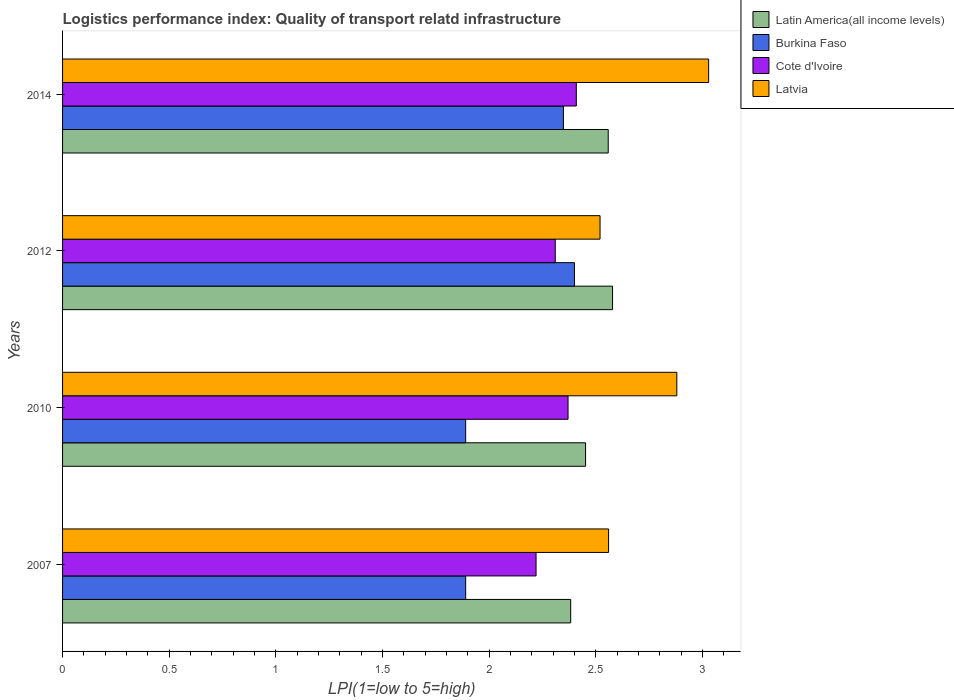How many groups of bars are there?
Make the answer very short. 4. Are the number of bars per tick equal to the number of legend labels?
Offer a terse response. Yes. Are the number of bars on each tick of the Y-axis equal?
Your answer should be compact. Yes. How many bars are there on the 1st tick from the top?
Your answer should be very brief. 4. How many bars are there on the 3rd tick from the bottom?
Give a very brief answer. 4. In how many cases, is the number of bars for a given year not equal to the number of legend labels?
Your response must be concise. 0. What is the logistics performance index in Burkina Faso in 2007?
Give a very brief answer. 1.89. Across all years, what is the maximum logistics performance index in Latin America(all income levels)?
Your answer should be compact. 2.58. Across all years, what is the minimum logistics performance index in Cote d'Ivoire?
Your answer should be compact. 2.22. What is the total logistics performance index in Burkina Faso in the graph?
Give a very brief answer. 8.53. What is the difference between the logistics performance index in Cote d'Ivoire in 2010 and that in 2012?
Provide a short and direct response. 0.06. What is the difference between the logistics performance index in Latvia in 2014 and the logistics performance index in Cote d'Ivoire in 2007?
Keep it short and to the point. 0.81. What is the average logistics performance index in Cote d'Ivoire per year?
Give a very brief answer. 2.33. In the year 2010, what is the difference between the logistics performance index in Latvia and logistics performance index in Cote d'Ivoire?
Your answer should be compact. 0.51. What is the ratio of the logistics performance index in Burkina Faso in 2007 to that in 2012?
Ensure brevity in your answer.  0.79. Is the logistics performance index in Latvia in 2007 less than that in 2012?
Your answer should be compact. No. Is the difference between the logistics performance index in Latvia in 2010 and 2014 greater than the difference between the logistics performance index in Cote d'Ivoire in 2010 and 2014?
Your answer should be compact. No. What is the difference between the highest and the second highest logistics performance index in Burkina Faso?
Your response must be concise. 0.05. What is the difference between the highest and the lowest logistics performance index in Burkina Faso?
Provide a succinct answer. 0.51. In how many years, is the logistics performance index in Burkina Faso greater than the average logistics performance index in Burkina Faso taken over all years?
Give a very brief answer. 2. Is it the case that in every year, the sum of the logistics performance index in Cote d'Ivoire and logistics performance index in Latvia is greater than the sum of logistics performance index in Burkina Faso and logistics performance index in Latin America(all income levels)?
Give a very brief answer. Yes. What does the 4th bar from the top in 2014 represents?
Ensure brevity in your answer.  Latin America(all income levels). What does the 1st bar from the bottom in 2010 represents?
Offer a terse response. Latin America(all income levels). Are all the bars in the graph horizontal?
Provide a succinct answer. Yes. What is the difference between two consecutive major ticks on the X-axis?
Ensure brevity in your answer.  0.5. Are the values on the major ticks of X-axis written in scientific E-notation?
Your response must be concise. No. Does the graph contain grids?
Make the answer very short. No. How are the legend labels stacked?
Make the answer very short. Vertical. What is the title of the graph?
Make the answer very short. Logistics performance index: Quality of transport relatd infrastructure. Does "Faeroe Islands" appear as one of the legend labels in the graph?
Ensure brevity in your answer.  No. What is the label or title of the X-axis?
Keep it short and to the point. LPI(1=low to 5=high). What is the label or title of the Y-axis?
Make the answer very short. Years. What is the LPI(1=low to 5=high) of Latin America(all income levels) in 2007?
Offer a very short reply. 2.38. What is the LPI(1=low to 5=high) in Burkina Faso in 2007?
Make the answer very short. 1.89. What is the LPI(1=low to 5=high) in Cote d'Ivoire in 2007?
Give a very brief answer. 2.22. What is the LPI(1=low to 5=high) in Latvia in 2007?
Your response must be concise. 2.56. What is the LPI(1=low to 5=high) in Latin America(all income levels) in 2010?
Ensure brevity in your answer.  2.45. What is the LPI(1=low to 5=high) of Burkina Faso in 2010?
Make the answer very short. 1.89. What is the LPI(1=low to 5=high) of Cote d'Ivoire in 2010?
Keep it short and to the point. 2.37. What is the LPI(1=low to 5=high) in Latvia in 2010?
Give a very brief answer. 2.88. What is the LPI(1=low to 5=high) in Latin America(all income levels) in 2012?
Make the answer very short. 2.58. What is the LPI(1=low to 5=high) of Burkina Faso in 2012?
Give a very brief answer. 2.4. What is the LPI(1=low to 5=high) of Cote d'Ivoire in 2012?
Ensure brevity in your answer.  2.31. What is the LPI(1=low to 5=high) in Latvia in 2012?
Keep it short and to the point. 2.52. What is the LPI(1=low to 5=high) of Latin America(all income levels) in 2014?
Provide a short and direct response. 2.56. What is the LPI(1=low to 5=high) of Burkina Faso in 2014?
Keep it short and to the point. 2.35. What is the LPI(1=low to 5=high) in Cote d'Ivoire in 2014?
Keep it short and to the point. 2.41. What is the LPI(1=low to 5=high) of Latvia in 2014?
Provide a short and direct response. 3.03. Across all years, what is the maximum LPI(1=low to 5=high) of Latin America(all income levels)?
Your answer should be compact. 2.58. Across all years, what is the maximum LPI(1=low to 5=high) of Burkina Faso?
Offer a very short reply. 2.4. Across all years, what is the maximum LPI(1=low to 5=high) of Cote d'Ivoire?
Make the answer very short. 2.41. Across all years, what is the maximum LPI(1=low to 5=high) of Latvia?
Provide a short and direct response. 3.03. Across all years, what is the minimum LPI(1=low to 5=high) in Latin America(all income levels)?
Provide a short and direct response. 2.38. Across all years, what is the minimum LPI(1=low to 5=high) of Burkina Faso?
Make the answer very short. 1.89. Across all years, what is the minimum LPI(1=low to 5=high) of Cote d'Ivoire?
Provide a succinct answer. 2.22. Across all years, what is the minimum LPI(1=low to 5=high) of Latvia?
Keep it short and to the point. 2.52. What is the total LPI(1=low to 5=high) in Latin America(all income levels) in the graph?
Your answer should be compact. 9.97. What is the total LPI(1=low to 5=high) of Burkina Faso in the graph?
Your answer should be compact. 8.53. What is the total LPI(1=low to 5=high) in Cote d'Ivoire in the graph?
Keep it short and to the point. 9.31. What is the total LPI(1=low to 5=high) in Latvia in the graph?
Ensure brevity in your answer.  10.99. What is the difference between the LPI(1=low to 5=high) in Latin America(all income levels) in 2007 and that in 2010?
Your answer should be very brief. -0.07. What is the difference between the LPI(1=low to 5=high) in Burkina Faso in 2007 and that in 2010?
Make the answer very short. 0. What is the difference between the LPI(1=low to 5=high) of Cote d'Ivoire in 2007 and that in 2010?
Offer a terse response. -0.15. What is the difference between the LPI(1=low to 5=high) in Latvia in 2007 and that in 2010?
Provide a succinct answer. -0.32. What is the difference between the LPI(1=low to 5=high) of Latin America(all income levels) in 2007 and that in 2012?
Make the answer very short. -0.2. What is the difference between the LPI(1=low to 5=high) in Burkina Faso in 2007 and that in 2012?
Make the answer very short. -0.51. What is the difference between the LPI(1=low to 5=high) of Cote d'Ivoire in 2007 and that in 2012?
Make the answer very short. -0.09. What is the difference between the LPI(1=low to 5=high) of Latvia in 2007 and that in 2012?
Ensure brevity in your answer.  0.04. What is the difference between the LPI(1=low to 5=high) in Latin America(all income levels) in 2007 and that in 2014?
Offer a very short reply. -0.18. What is the difference between the LPI(1=low to 5=high) in Burkina Faso in 2007 and that in 2014?
Ensure brevity in your answer.  -0.46. What is the difference between the LPI(1=low to 5=high) in Cote d'Ivoire in 2007 and that in 2014?
Give a very brief answer. -0.19. What is the difference between the LPI(1=low to 5=high) in Latvia in 2007 and that in 2014?
Make the answer very short. -0.47. What is the difference between the LPI(1=low to 5=high) in Latin America(all income levels) in 2010 and that in 2012?
Your answer should be compact. -0.13. What is the difference between the LPI(1=low to 5=high) of Burkina Faso in 2010 and that in 2012?
Give a very brief answer. -0.51. What is the difference between the LPI(1=low to 5=high) of Cote d'Ivoire in 2010 and that in 2012?
Make the answer very short. 0.06. What is the difference between the LPI(1=low to 5=high) of Latvia in 2010 and that in 2012?
Offer a very short reply. 0.36. What is the difference between the LPI(1=low to 5=high) of Latin America(all income levels) in 2010 and that in 2014?
Ensure brevity in your answer.  -0.11. What is the difference between the LPI(1=low to 5=high) of Burkina Faso in 2010 and that in 2014?
Provide a short and direct response. -0.46. What is the difference between the LPI(1=low to 5=high) in Cote d'Ivoire in 2010 and that in 2014?
Your response must be concise. -0.04. What is the difference between the LPI(1=low to 5=high) of Latvia in 2010 and that in 2014?
Offer a very short reply. -0.15. What is the difference between the LPI(1=low to 5=high) of Latin America(all income levels) in 2012 and that in 2014?
Offer a terse response. 0.02. What is the difference between the LPI(1=low to 5=high) of Burkina Faso in 2012 and that in 2014?
Keep it short and to the point. 0.05. What is the difference between the LPI(1=low to 5=high) in Cote d'Ivoire in 2012 and that in 2014?
Keep it short and to the point. -0.1. What is the difference between the LPI(1=low to 5=high) of Latvia in 2012 and that in 2014?
Make the answer very short. -0.51. What is the difference between the LPI(1=low to 5=high) of Latin America(all income levels) in 2007 and the LPI(1=low to 5=high) of Burkina Faso in 2010?
Offer a very short reply. 0.49. What is the difference between the LPI(1=low to 5=high) in Latin America(all income levels) in 2007 and the LPI(1=low to 5=high) in Cote d'Ivoire in 2010?
Keep it short and to the point. 0.01. What is the difference between the LPI(1=low to 5=high) of Latin America(all income levels) in 2007 and the LPI(1=low to 5=high) of Latvia in 2010?
Offer a very short reply. -0.5. What is the difference between the LPI(1=low to 5=high) in Burkina Faso in 2007 and the LPI(1=low to 5=high) in Cote d'Ivoire in 2010?
Your response must be concise. -0.48. What is the difference between the LPI(1=low to 5=high) in Burkina Faso in 2007 and the LPI(1=low to 5=high) in Latvia in 2010?
Your response must be concise. -0.99. What is the difference between the LPI(1=low to 5=high) of Cote d'Ivoire in 2007 and the LPI(1=low to 5=high) of Latvia in 2010?
Make the answer very short. -0.66. What is the difference between the LPI(1=low to 5=high) of Latin America(all income levels) in 2007 and the LPI(1=low to 5=high) of Burkina Faso in 2012?
Keep it short and to the point. -0.02. What is the difference between the LPI(1=low to 5=high) in Latin America(all income levels) in 2007 and the LPI(1=low to 5=high) in Cote d'Ivoire in 2012?
Ensure brevity in your answer.  0.07. What is the difference between the LPI(1=low to 5=high) in Latin America(all income levels) in 2007 and the LPI(1=low to 5=high) in Latvia in 2012?
Provide a succinct answer. -0.14. What is the difference between the LPI(1=low to 5=high) in Burkina Faso in 2007 and the LPI(1=low to 5=high) in Cote d'Ivoire in 2012?
Keep it short and to the point. -0.42. What is the difference between the LPI(1=low to 5=high) in Burkina Faso in 2007 and the LPI(1=low to 5=high) in Latvia in 2012?
Ensure brevity in your answer.  -0.63. What is the difference between the LPI(1=low to 5=high) in Latin America(all income levels) in 2007 and the LPI(1=low to 5=high) in Burkina Faso in 2014?
Make the answer very short. 0.03. What is the difference between the LPI(1=low to 5=high) in Latin America(all income levels) in 2007 and the LPI(1=low to 5=high) in Cote d'Ivoire in 2014?
Offer a terse response. -0.03. What is the difference between the LPI(1=low to 5=high) of Latin America(all income levels) in 2007 and the LPI(1=low to 5=high) of Latvia in 2014?
Your response must be concise. -0.65. What is the difference between the LPI(1=low to 5=high) in Burkina Faso in 2007 and the LPI(1=low to 5=high) in Cote d'Ivoire in 2014?
Offer a very short reply. -0.52. What is the difference between the LPI(1=low to 5=high) of Burkina Faso in 2007 and the LPI(1=low to 5=high) of Latvia in 2014?
Make the answer very short. -1.14. What is the difference between the LPI(1=low to 5=high) of Cote d'Ivoire in 2007 and the LPI(1=low to 5=high) of Latvia in 2014?
Give a very brief answer. -0.81. What is the difference between the LPI(1=low to 5=high) of Latin America(all income levels) in 2010 and the LPI(1=low to 5=high) of Burkina Faso in 2012?
Your answer should be very brief. 0.05. What is the difference between the LPI(1=low to 5=high) in Latin America(all income levels) in 2010 and the LPI(1=low to 5=high) in Cote d'Ivoire in 2012?
Offer a terse response. 0.14. What is the difference between the LPI(1=low to 5=high) of Latin America(all income levels) in 2010 and the LPI(1=low to 5=high) of Latvia in 2012?
Your response must be concise. -0.07. What is the difference between the LPI(1=low to 5=high) in Burkina Faso in 2010 and the LPI(1=low to 5=high) in Cote d'Ivoire in 2012?
Provide a succinct answer. -0.42. What is the difference between the LPI(1=low to 5=high) of Burkina Faso in 2010 and the LPI(1=low to 5=high) of Latvia in 2012?
Provide a succinct answer. -0.63. What is the difference between the LPI(1=low to 5=high) in Cote d'Ivoire in 2010 and the LPI(1=low to 5=high) in Latvia in 2012?
Provide a succinct answer. -0.15. What is the difference between the LPI(1=low to 5=high) in Latin America(all income levels) in 2010 and the LPI(1=low to 5=high) in Burkina Faso in 2014?
Provide a succinct answer. 0.1. What is the difference between the LPI(1=low to 5=high) in Latin America(all income levels) in 2010 and the LPI(1=low to 5=high) in Cote d'Ivoire in 2014?
Offer a very short reply. 0.04. What is the difference between the LPI(1=low to 5=high) of Latin America(all income levels) in 2010 and the LPI(1=low to 5=high) of Latvia in 2014?
Your response must be concise. -0.58. What is the difference between the LPI(1=low to 5=high) of Burkina Faso in 2010 and the LPI(1=low to 5=high) of Cote d'Ivoire in 2014?
Provide a short and direct response. -0.52. What is the difference between the LPI(1=low to 5=high) of Burkina Faso in 2010 and the LPI(1=low to 5=high) of Latvia in 2014?
Give a very brief answer. -1.14. What is the difference between the LPI(1=low to 5=high) in Cote d'Ivoire in 2010 and the LPI(1=low to 5=high) in Latvia in 2014?
Offer a very short reply. -0.66. What is the difference between the LPI(1=low to 5=high) in Latin America(all income levels) in 2012 and the LPI(1=low to 5=high) in Burkina Faso in 2014?
Offer a very short reply. 0.23. What is the difference between the LPI(1=low to 5=high) in Latin America(all income levels) in 2012 and the LPI(1=low to 5=high) in Cote d'Ivoire in 2014?
Your answer should be compact. 0.17. What is the difference between the LPI(1=low to 5=high) of Latin America(all income levels) in 2012 and the LPI(1=low to 5=high) of Latvia in 2014?
Offer a very short reply. -0.45. What is the difference between the LPI(1=low to 5=high) in Burkina Faso in 2012 and the LPI(1=low to 5=high) in Cote d'Ivoire in 2014?
Ensure brevity in your answer.  -0.01. What is the difference between the LPI(1=low to 5=high) of Burkina Faso in 2012 and the LPI(1=low to 5=high) of Latvia in 2014?
Keep it short and to the point. -0.63. What is the difference between the LPI(1=low to 5=high) in Cote d'Ivoire in 2012 and the LPI(1=low to 5=high) in Latvia in 2014?
Your answer should be compact. -0.72. What is the average LPI(1=low to 5=high) in Latin America(all income levels) per year?
Keep it short and to the point. 2.49. What is the average LPI(1=low to 5=high) of Burkina Faso per year?
Ensure brevity in your answer.  2.13. What is the average LPI(1=low to 5=high) in Cote d'Ivoire per year?
Provide a short and direct response. 2.33. What is the average LPI(1=low to 5=high) of Latvia per year?
Keep it short and to the point. 2.75. In the year 2007, what is the difference between the LPI(1=low to 5=high) in Latin America(all income levels) and LPI(1=low to 5=high) in Burkina Faso?
Provide a short and direct response. 0.49. In the year 2007, what is the difference between the LPI(1=low to 5=high) of Latin America(all income levels) and LPI(1=low to 5=high) of Cote d'Ivoire?
Keep it short and to the point. 0.16. In the year 2007, what is the difference between the LPI(1=low to 5=high) of Latin America(all income levels) and LPI(1=low to 5=high) of Latvia?
Make the answer very short. -0.18. In the year 2007, what is the difference between the LPI(1=low to 5=high) in Burkina Faso and LPI(1=low to 5=high) in Cote d'Ivoire?
Your response must be concise. -0.33. In the year 2007, what is the difference between the LPI(1=low to 5=high) in Burkina Faso and LPI(1=low to 5=high) in Latvia?
Ensure brevity in your answer.  -0.67. In the year 2007, what is the difference between the LPI(1=low to 5=high) in Cote d'Ivoire and LPI(1=low to 5=high) in Latvia?
Offer a very short reply. -0.34. In the year 2010, what is the difference between the LPI(1=low to 5=high) in Latin America(all income levels) and LPI(1=low to 5=high) in Burkina Faso?
Provide a short and direct response. 0.56. In the year 2010, what is the difference between the LPI(1=low to 5=high) in Latin America(all income levels) and LPI(1=low to 5=high) in Cote d'Ivoire?
Make the answer very short. 0.08. In the year 2010, what is the difference between the LPI(1=low to 5=high) in Latin America(all income levels) and LPI(1=low to 5=high) in Latvia?
Ensure brevity in your answer.  -0.43. In the year 2010, what is the difference between the LPI(1=low to 5=high) in Burkina Faso and LPI(1=low to 5=high) in Cote d'Ivoire?
Give a very brief answer. -0.48. In the year 2010, what is the difference between the LPI(1=low to 5=high) of Burkina Faso and LPI(1=low to 5=high) of Latvia?
Ensure brevity in your answer.  -0.99. In the year 2010, what is the difference between the LPI(1=low to 5=high) of Cote d'Ivoire and LPI(1=low to 5=high) of Latvia?
Provide a short and direct response. -0.51. In the year 2012, what is the difference between the LPI(1=low to 5=high) in Latin America(all income levels) and LPI(1=low to 5=high) in Burkina Faso?
Give a very brief answer. 0.18. In the year 2012, what is the difference between the LPI(1=low to 5=high) of Latin America(all income levels) and LPI(1=low to 5=high) of Cote d'Ivoire?
Offer a terse response. 0.27. In the year 2012, what is the difference between the LPI(1=low to 5=high) of Latin America(all income levels) and LPI(1=low to 5=high) of Latvia?
Your answer should be very brief. 0.06. In the year 2012, what is the difference between the LPI(1=low to 5=high) of Burkina Faso and LPI(1=low to 5=high) of Cote d'Ivoire?
Give a very brief answer. 0.09. In the year 2012, what is the difference between the LPI(1=low to 5=high) of Burkina Faso and LPI(1=low to 5=high) of Latvia?
Your response must be concise. -0.12. In the year 2012, what is the difference between the LPI(1=low to 5=high) of Cote d'Ivoire and LPI(1=low to 5=high) of Latvia?
Your answer should be very brief. -0.21. In the year 2014, what is the difference between the LPI(1=low to 5=high) in Latin America(all income levels) and LPI(1=low to 5=high) in Burkina Faso?
Provide a short and direct response. 0.21. In the year 2014, what is the difference between the LPI(1=low to 5=high) in Latin America(all income levels) and LPI(1=low to 5=high) in Cote d'Ivoire?
Give a very brief answer. 0.15. In the year 2014, what is the difference between the LPI(1=low to 5=high) of Latin America(all income levels) and LPI(1=low to 5=high) of Latvia?
Make the answer very short. -0.47. In the year 2014, what is the difference between the LPI(1=low to 5=high) of Burkina Faso and LPI(1=low to 5=high) of Cote d'Ivoire?
Your answer should be very brief. -0.06. In the year 2014, what is the difference between the LPI(1=low to 5=high) in Burkina Faso and LPI(1=low to 5=high) in Latvia?
Your response must be concise. -0.68. In the year 2014, what is the difference between the LPI(1=low to 5=high) in Cote d'Ivoire and LPI(1=low to 5=high) in Latvia?
Give a very brief answer. -0.62. What is the ratio of the LPI(1=low to 5=high) of Latin America(all income levels) in 2007 to that in 2010?
Your answer should be very brief. 0.97. What is the ratio of the LPI(1=low to 5=high) in Cote d'Ivoire in 2007 to that in 2010?
Offer a terse response. 0.94. What is the ratio of the LPI(1=low to 5=high) of Latvia in 2007 to that in 2010?
Your answer should be very brief. 0.89. What is the ratio of the LPI(1=low to 5=high) in Latin America(all income levels) in 2007 to that in 2012?
Your answer should be compact. 0.92. What is the ratio of the LPI(1=low to 5=high) of Burkina Faso in 2007 to that in 2012?
Provide a succinct answer. 0.79. What is the ratio of the LPI(1=low to 5=high) of Latvia in 2007 to that in 2012?
Keep it short and to the point. 1.02. What is the ratio of the LPI(1=low to 5=high) in Latin America(all income levels) in 2007 to that in 2014?
Offer a terse response. 0.93. What is the ratio of the LPI(1=low to 5=high) of Burkina Faso in 2007 to that in 2014?
Your answer should be very brief. 0.8. What is the ratio of the LPI(1=low to 5=high) of Cote d'Ivoire in 2007 to that in 2014?
Offer a terse response. 0.92. What is the ratio of the LPI(1=low to 5=high) in Latvia in 2007 to that in 2014?
Keep it short and to the point. 0.85. What is the ratio of the LPI(1=low to 5=high) in Latin America(all income levels) in 2010 to that in 2012?
Keep it short and to the point. 0.95. What is the ratio of the LPI(1=low to 5=high) of Burkina Faso in 2010 to that in 2012?
Give a very brief answer. 0.79. What is the ratio of the LPI(1=low to 5=high) in Cote d'Ivoire in 2010 to that in 2012?
Ensure brevity in your answer.  1.03. What is the ratio of the LPI(1=low to 5=high) of Latin America(all income levels) in 2010 to that in 2014?
Offer a terse response. 0.96. What is the ratio of the LPI(1=low to 5=high) of Burkina Faso in 2010 to that in 2014?
Make the answer very short. 0.8. What is the ratio of the LPI(1=low to 5=high) in Cote d'Ivoire in 2010 to that in 2014?
Offer a terse response. 0.98. What is the ratio of the LPI(1=low to 5=high) of Latvia in 2010 to that in 2014?
Give a very brief answer. 0.95. What is the ratio of the LPI(1=low to 5=high) in Latin America(all income levels) in 2012 to that in 2014?
Give a very brief answer. 1.01. What is the ratio of the LPI(1=low to 5=high) in Burkina Faso in 2012 to that in 2014?
Make the answer very short. 1.02. What is the ratio of the LPI(1=low to 5=high) of Cote d'Ivoire in 2012 to that in 2014?
Offer a terse response. 0.96. What is the ratio of the LPI(1=low to 5=high) of Latvia in 2012 to that in 2014?
Provide a succinct answer. 0.83. What is the difference between the highest and the second highest LPI(1=low to 5=high) in Latin America(all income levels)?
Your answer should be compact. 0.02. What is the difference between the highest and the second highest LPI(1=low to 5=high) of Burkina Faso?
Offer a very short reply. 0.05. What is the difference between the highest and the second highest LPI(1=low to 5=high) in Cote d'Ivoire?
Keep it short and to the point. 0.04. What is the difference between the highest and the second highest LPI(1=low to 5=high) in Latvia?
Give a very brief answer. 0.15. What is the difference between the highest and the lowest LPI(1=low to 5=high) in Latin America(all income levels)?
Offer a very short reply. 0.2. What is the difference between the highest and the lowest LPI(1=low to 5=high) of Burkina Faso?
Provide a succinct answer. 0.51. What is the difference between the highest and the lowest LPI(1=low to 5=high) of Cote d'Ivoire?
Provide a succinct answer. 0.19. What is the difference between the highest and the lowest LPI(1=low to 5=high) in Latvia?
Provide a short and direct response. 0.51. 